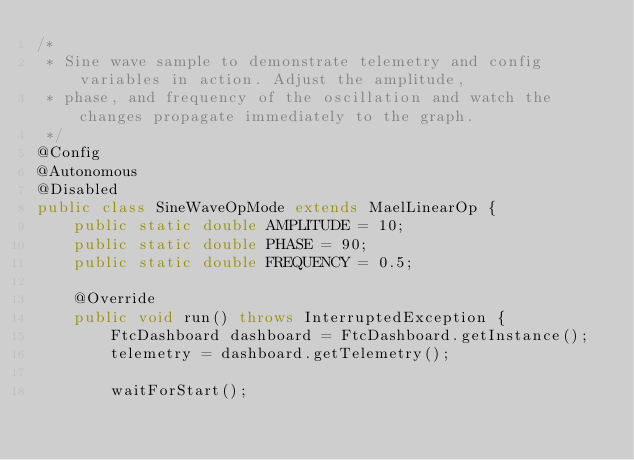<code> <loc_0><loc_0><loc_500><loc_500><_Java_>/*
 * Sine wave sample to demonstrate telemetry and config variables in action. Adjust the amplitude,
 * phase, and frequency of the oscillation and watch the changes propagate immediately to the graph.
 */
@Config
@Autonomous
@Disabled
public class SineWaveOpMode extends MaelLinearOp {
    public static double AMPLITUDE = 10;
    public static double PHASE = 90;
    public static double FREQUENCY = 0.5;

    @Override
    public void run() throws InterruptedException {
        FtcDashboard dashboard = FtcDashboard.getInstance();
        telemetry = dashboard.getTelemetry();

        waitForStart();
</code> 